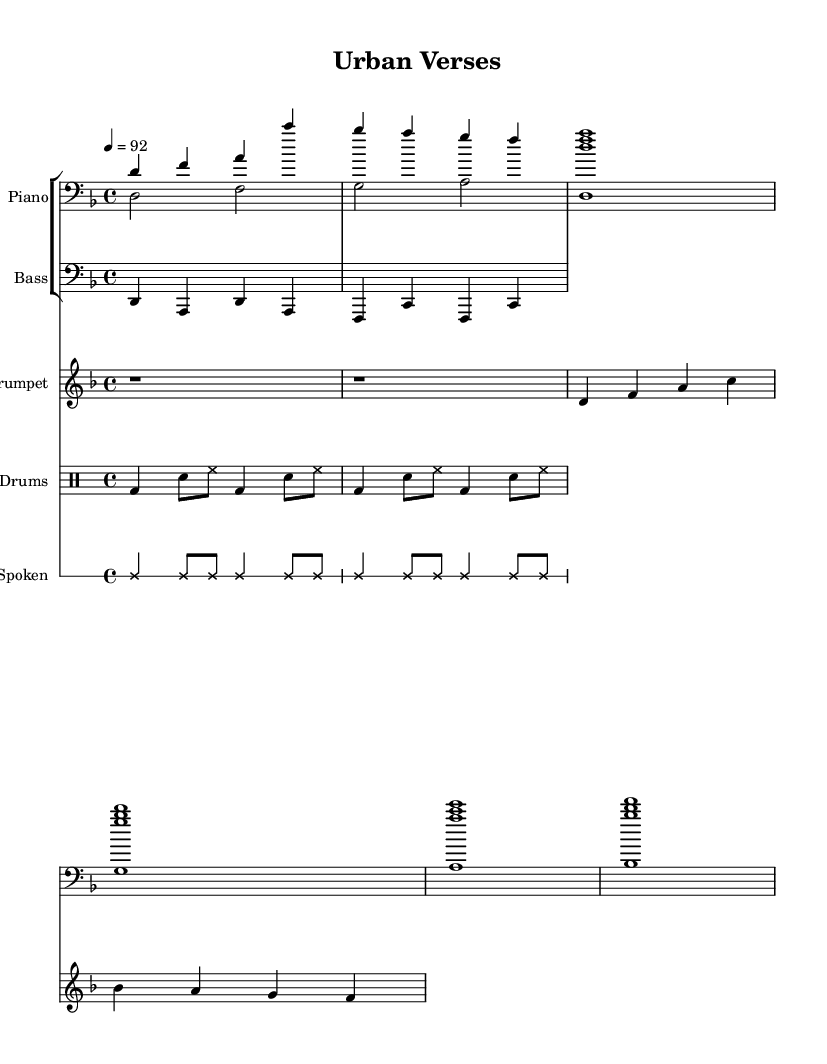What is the key signature of this music? The key signature of the music is D minor, indicated by the presence of one flat (B flat) in the notation.
Answer: D minor What is the time signature of this piece? The time signature is found at the beginning of the score, which shows 4/4, meaning there are four beats per measure.
Answer: 4/4 What is the tempo marking for this piece? The tempo marking indicates the speed and is indicated as 4 = 92, meaning there are 92 beats per minute (quarter notes).
Answer: 92 How many voices are in the piano section? By identifying the parts under the piano staff, we can see there are two voices: one for the right hand and one for the left hand.
Answer: Two What type of musical elements are fused in this composition? The combination of spoken word, jazz elements, and hip hop beats reflects a fusion of different musical styles, specifically integrating vocal poetry and improvised jazz.
Answer: Spoken word, jazz, hip hop What is the rhythm style of the spoken word section? The spoken word section is notated in a cross notehead style, indicating a rhythm that is spoken rather than sung or played musically, typically reflecting the flow of spoken poetry.
Answer: Speaking rhythm Which instruments are featured in the ensemble? By analyzing the staff names and their corresponding parts, the instruments present are the piano, bass, trumpet, drums, and spoken word.
Answer: Piano, bass, trumpet, drums, spoken word 